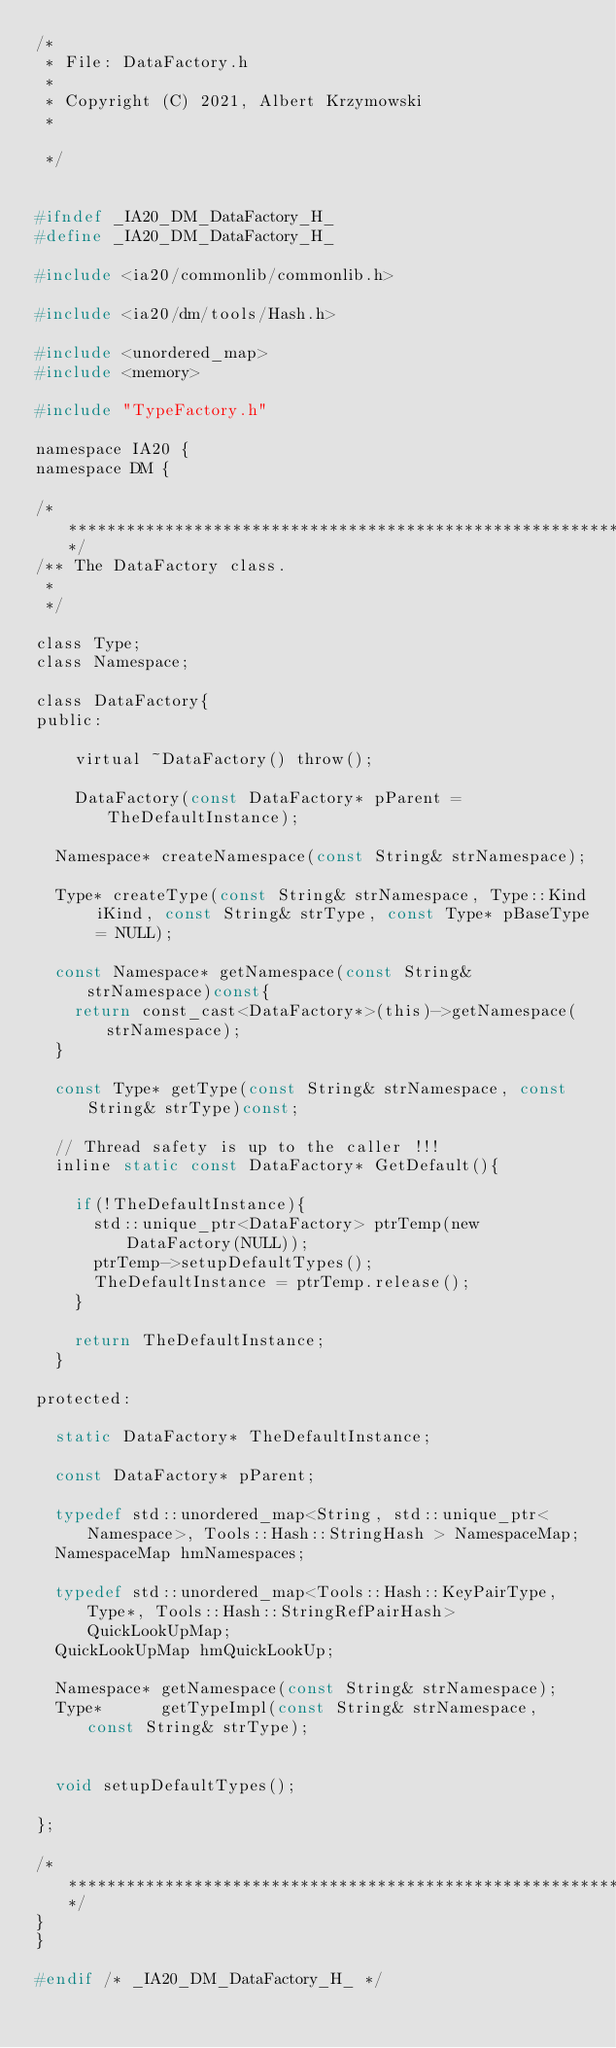Convert code to text. <code><loc_0><loc_0><loc_500><loc_500><_C_>/*
 * File: DataFactory.h
 *
 * Copyright (C) 2021, Albert Krzymowski
 *

 */


#ifndef _IA20_DM_DataFactory_H_
#define _IA20_DM_DataFactory_H_

#include <ia20/commonlib/commonlib.h>

#include <ia20/dm/tools/Hash.h>

#include <unordered_map>
#include <memory>

#include "TypeFactory.h"

namespace IA20 {
namespace DM {

/*************************************************************************/
/** The DataFactory class.
 *
 */

class Type;
class Namespace;

class DataFactory{
public:

	virtual ~DataFactory() throw();

	DataFactory(const DataFactory* pParent = TheDefaultInstance);

  Namespace* createNamespace(const String& strNamespace);

  Type* createType(const String& strNamespace, Type::Kind iKind, const String& strType, const Type* pBaseType = NULL);

  const Namespace* getNamespace(const String& strNamespace)const{
    return const_cast<DataFactory*>(this)->getNamespace(strNamespace);
  }

  const Type* getType(const String& strNamespace, const String& strType)const;

  // Thread safety is up to the caller !!!
  inline static const DataFactory* GetDefault(){

    if(!TheDefaultInstance){
      std::unique_ptr<DataFactory> ptrTemp(new DataFactory(NULL));
      ptrTemp->setupDefaultTypes();
      TheDefaultInstance = ptrTemp.release();
    }

    return TheDefaultInstance;
  }

protected:

  static DataFactory* TheDefaultInstance;

  const DataFactory* pParent;

  typedef std::unordered_map<String, std::unique_ptr<Namespace>, Tools::Hash::StringHash > NamespaceMap;
  NamespaceMap hmNamespaces;

  typedef std::unordered_map<Tools::Hash::KeyPairType, Type*, Tools::Hash::StringRefPairHash> QuickLookUpMap;
  QuickLookUpMap hmQuickLookUp;

  Namespace* getNamespace(const String& strNamespace);
  Type*      getTypeImpl(const String& strNamespace, const String& strType);


  void setupDefaultTypes();

};

/*************************************************************************/
}
}

#endif /* _IA20_DM_DataFactory_H_ */
</code> 